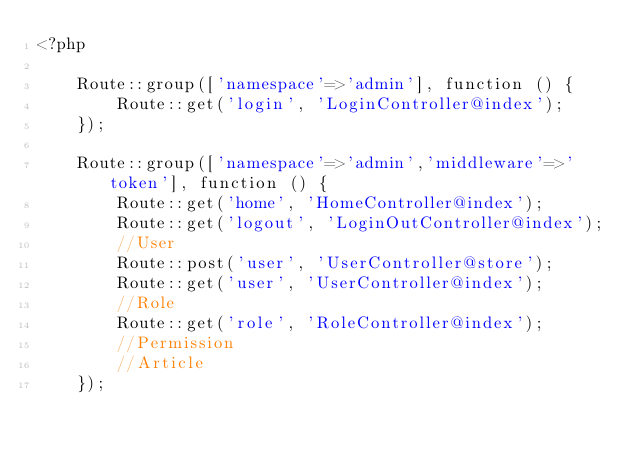Convert code to text. <code><loc_0><loc_0><loc_500><loc_500><_PHP_><?php

    Route::group(['namespace'=>'admin'], function () {
        Route::get('login', 'LoginController@index');
    });

    Route::group(['namespace'=>'admin','middleware'=>'token'], function () {
        Route::get('home', 'HomeController@index');
        Route::get('logout', 'LoginOutController@index');
        //User
        Route::post('user', 'UserController@store');
        Route::get('user', 'UserController@index');
        //Role
        Route::get('role', 'RoleController@index');
        //Permission
        //Article
    });
</code> 